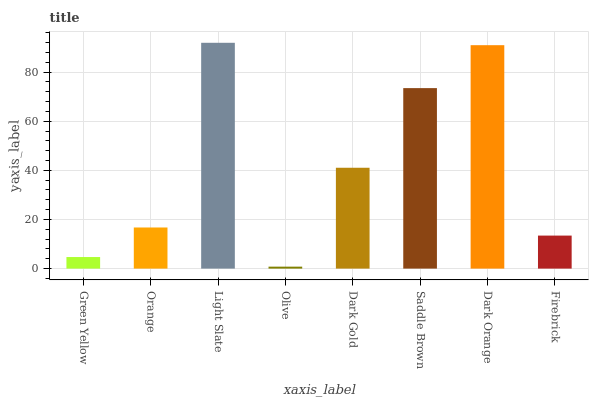Is Orange the minimum?
Answer yes or no. No. Is Orange the maximum?
Answer yes or no. No. Is Orange greater than Green Yellow?
Answer yes or no. Yes. Is Green Yellow less than Orange?
Answer yes or no. Yes. Is Green Yellow greater than Orange?
Answer yes or no. No. Is Orange less than Green Yellow?
Answer yes or no. No. Is Dark Gold the high median?
Answer yes or no. Yes. Is Orange the low median?
Answer yes or no. Yes. Is Olive the high median?
Answer yes or no. No. Is Olive the low median?
Answer yes or no. No. 